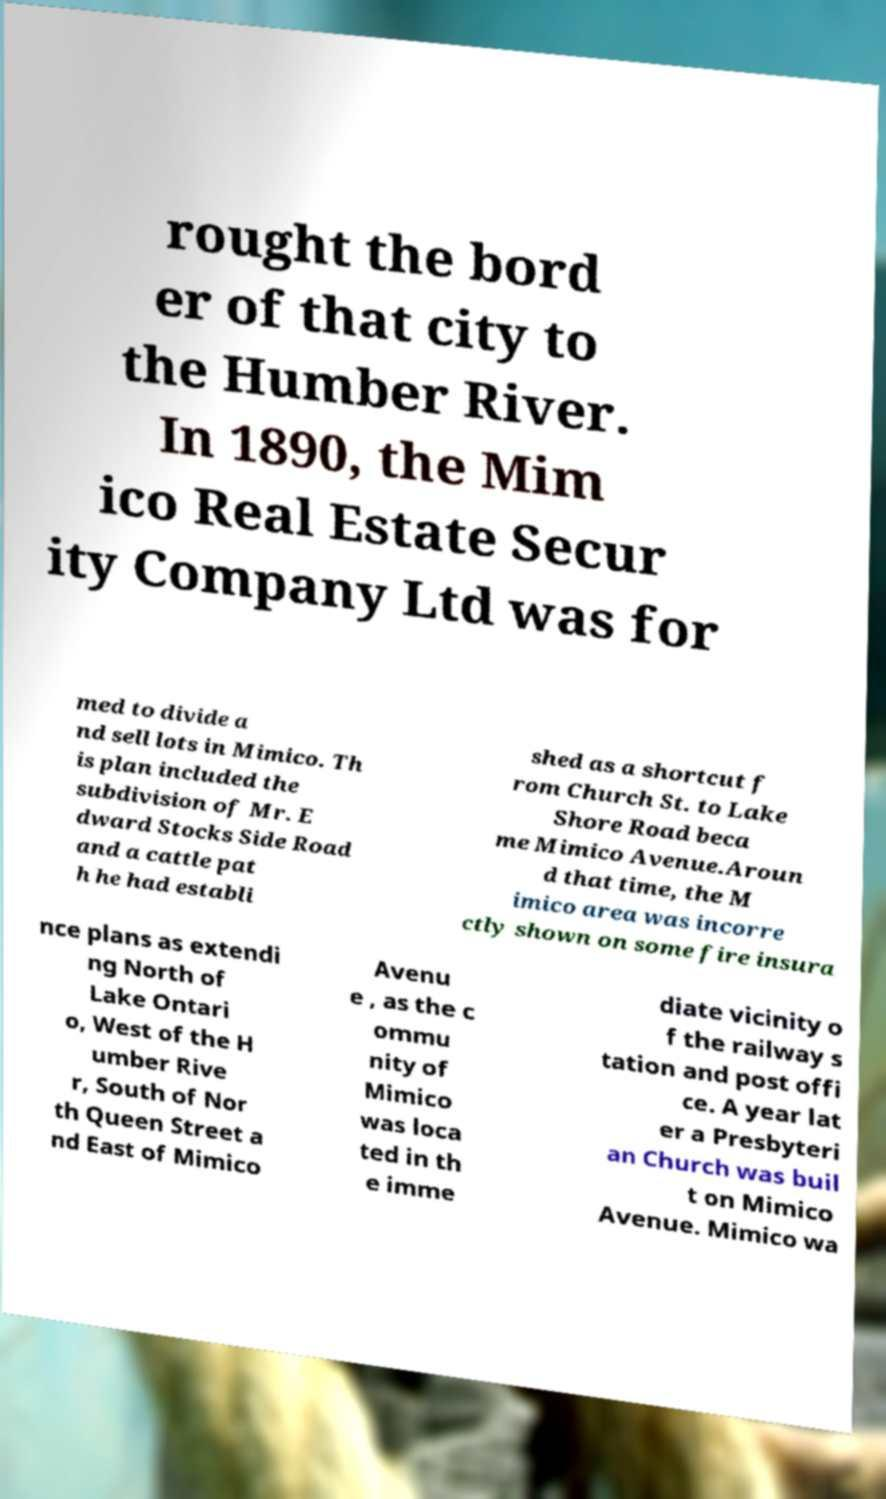Can you read and provide the text displayed in the image?This photo seems to have some interesting text. Can you extract and type it out for me? rought the bord er of that city to the Humber River. In 1890, the Mim ico Real Estate Secur ity Company Ltd was for med to divide a nd sell lots in Mimico. Th is plan included the subdivision of Mr. E dward Stocks Side Road and a cattle pat h he had establi shed as a shortcut f rom Church St. to Lake Shore Road beca me Mimico Avenue.Aroun d that time, the M imico area was incorre ctly shown on some fire insura nce plans as extendi ng North of Lake Ontari o, West of the H umber Rive r, South of Nor th Queen Street a nd East of Mimico Avenu e , as the c ommu nity of Mimico was loca ted in th e imme diate vicinity o f the railway s tation and post offi ce. A year lat er a Presbyteri an Church was buil t on Mimico Avenue. Mimico wa 